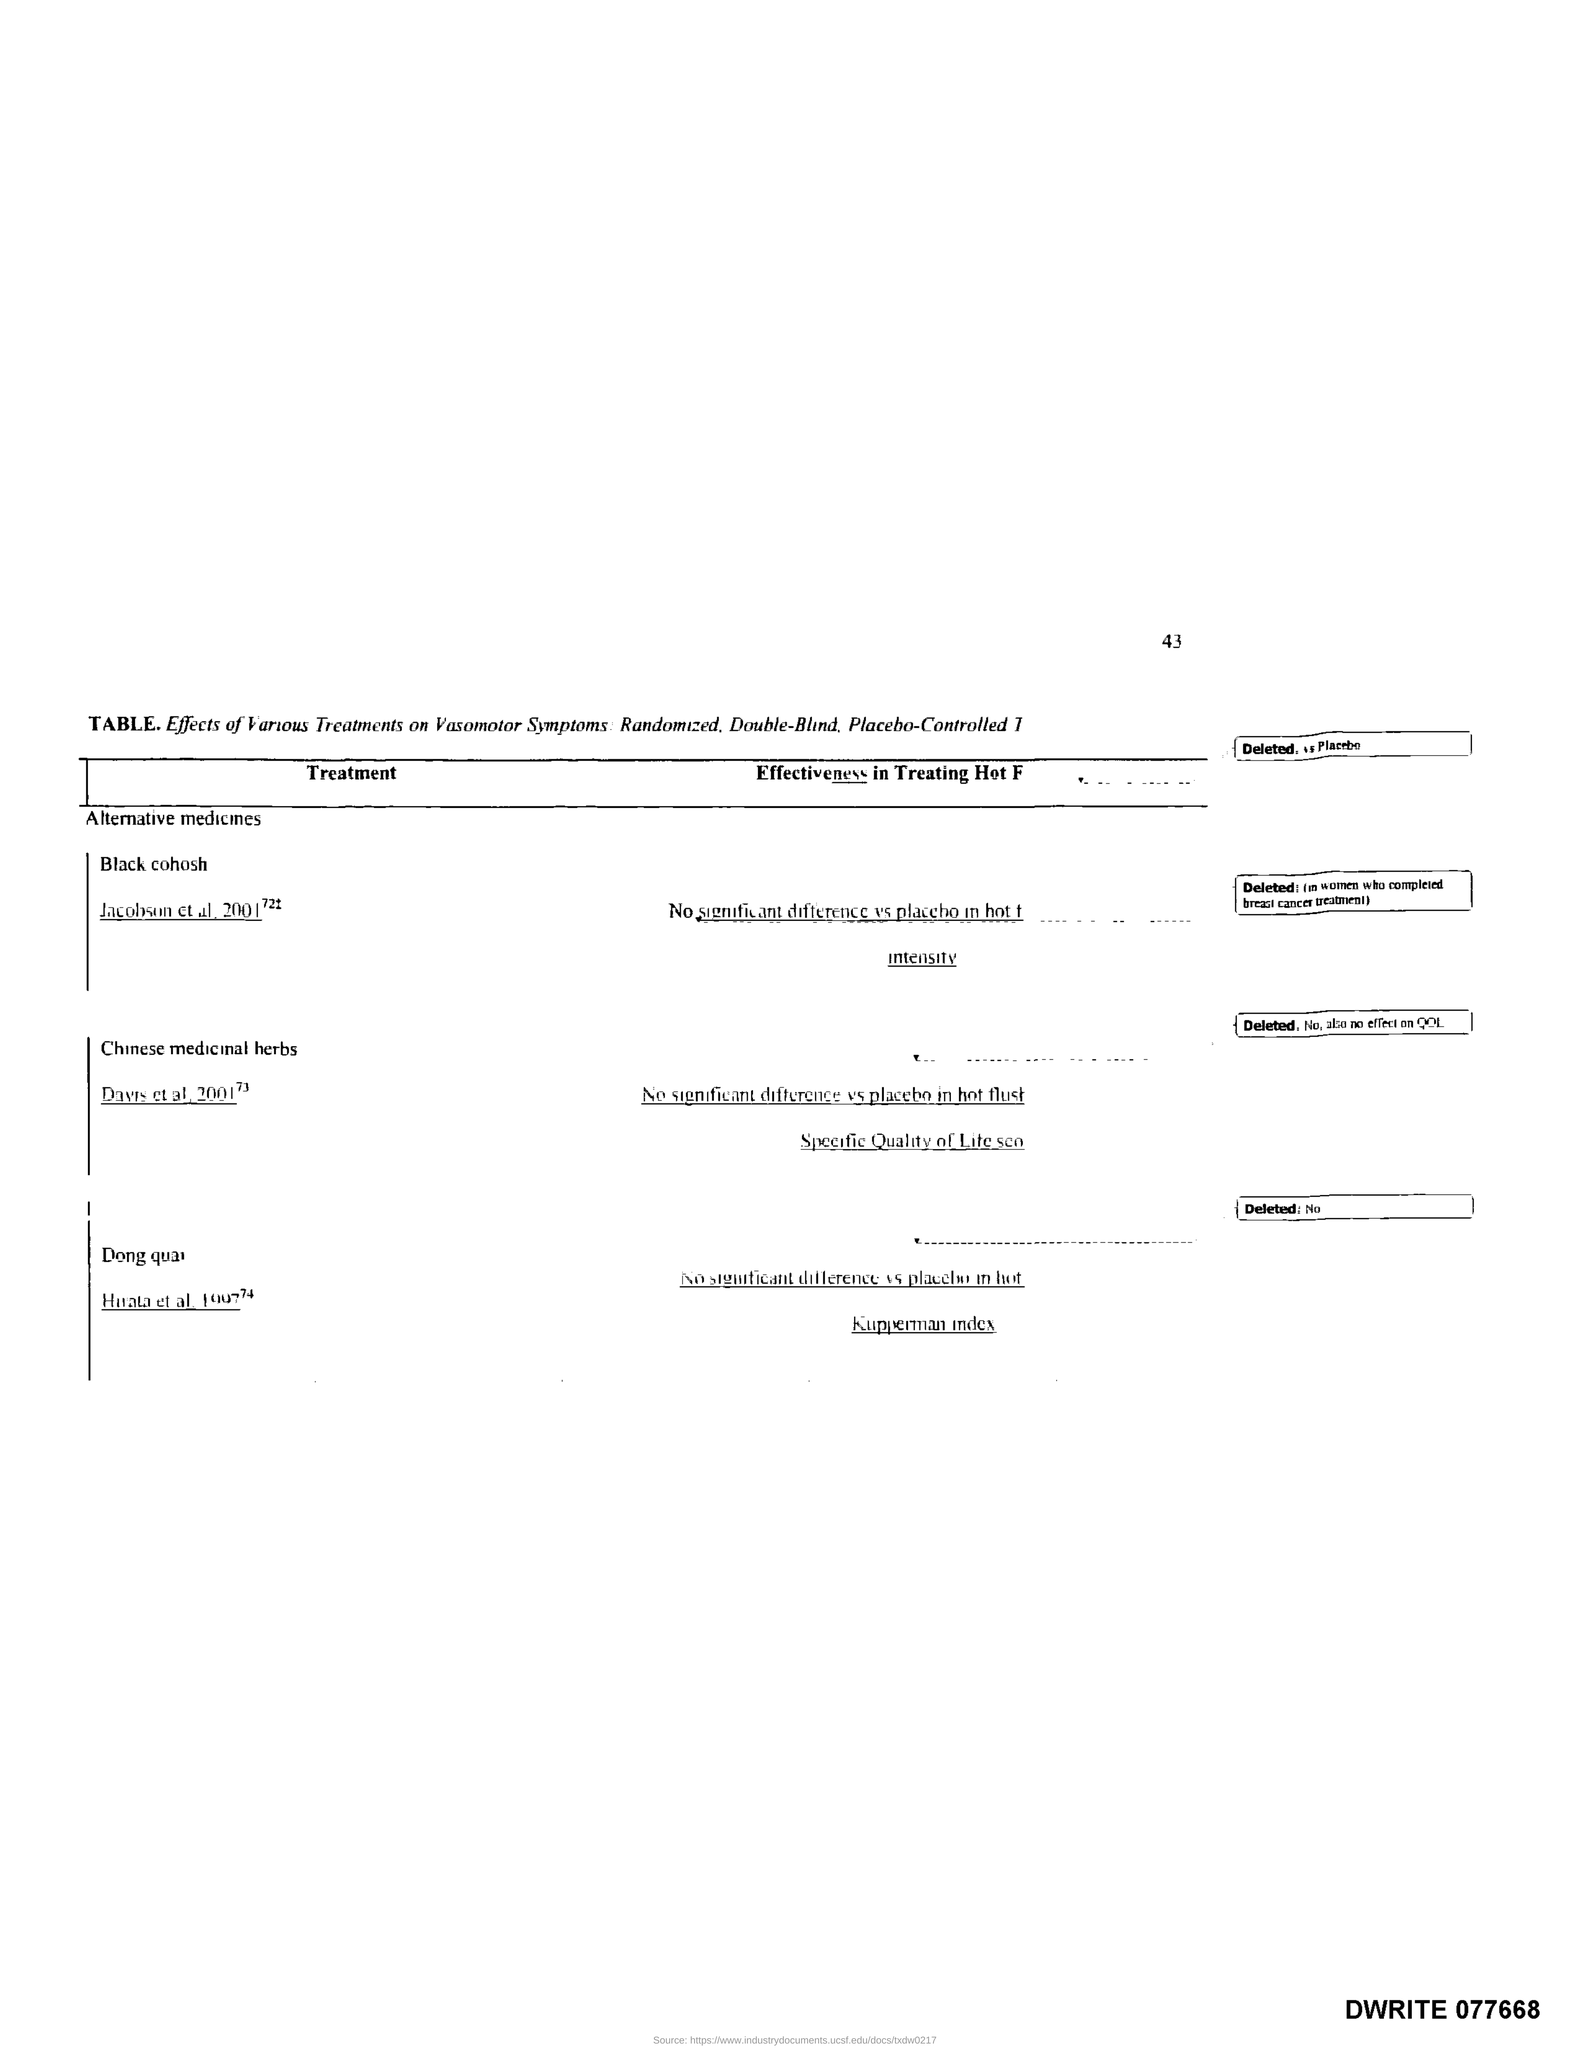Highlight a few significant elements in this photo. What is the title of the first column of the table? It is named 'Treatment.' 